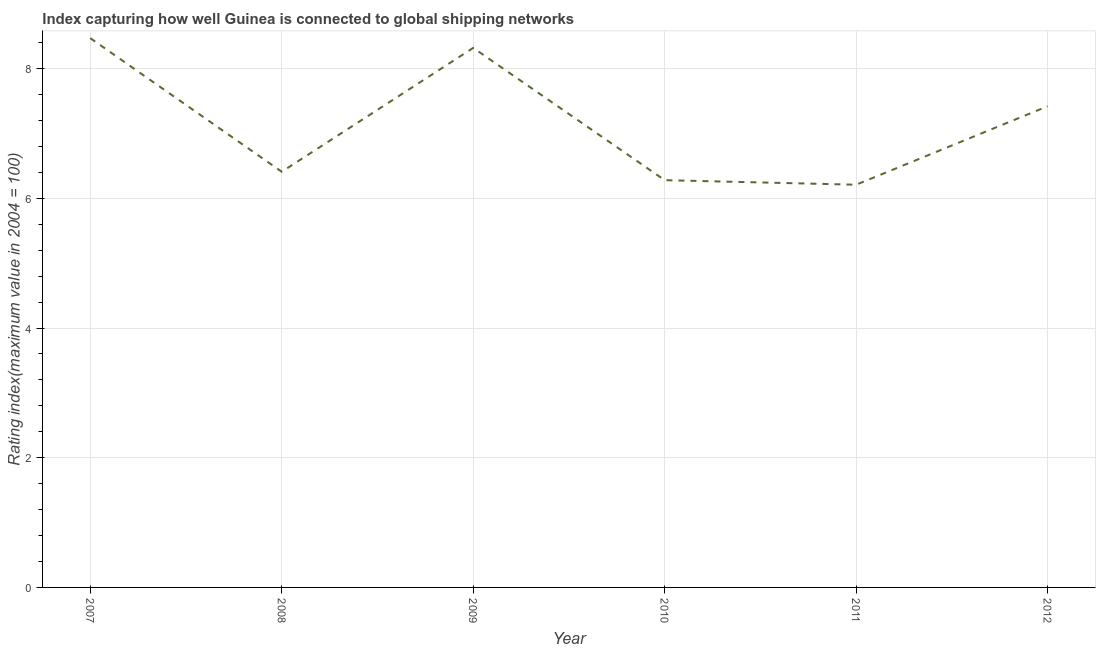What is the liner shipping connectivity index in 2009?
Offer a terse response. 8.32. Across all years, what is the maximum liner shipping connectivity index?
Your answer should be very brief. 8.47. Across all years, what is the minimum liner shipping connectivity index?
Your answer should be very brief. 6.21. In which year was the liner shipping connectivity index minimum?
Keep it short and to the point. 2011. What is the sum of the liner shipping connectivity index?
Your answer should be compact. 43.11. What is the difference between the liner shipping connectivity index in 2011 and 2012?
Your answer should be very brief. -1.21. What is the average liner shipping connectivity index per year?
Give a very brief answer. 7.19. What is the median liner shipping connectivity index?
Make the answer very short. 6.92. What is the ratio of the liner shipping connectivity index in 2008 to that in 2009?
Give a very brief answer. 0.77. Is the liner shipping connectivity index in 2007 less than that in 2011?
Make the answer very short. No. Is the difference between the liner shipping connectivity index in 2008 and 2010 greater than the difference between any two years?
Your response must be concise. No. What is the difference between the highest and the second highest liner shipping connectivity index?
Give a very brief answer. 0.15. What is the difference between the highest and the lowest liner shipping connectivity index?
Ensure brevity in your answer.  2.26. How many lines are there?
Ensure brevity in your answer.  1. Are the values on the major ticks of Y-axis written in scientific E-notation?
Your response must be concise. No. Does the graph contain any zero values?
Provide a short and direct response. No. Does the graph contain grids?
Offer a very short reply. Yes. What is the title of the graph?
Provide a short and direct response. Index capturing how well Guinea is connected to global shipping networks. What is the label or title of the X-axis?
Keep it short and to the point. Year. What is the label or title of the Y-axis?
Make the answer very short. Rating index(maximum value in 2004 = 100). What is the Rating index(maximum value in 2004 = 100) of 2007?
Make the answer very short. 8.47. What is the Rating index(maximum value in 2004 = 100) of 2008?
Keep it short and to the point. 6.41. What is the Rating index(maximum value in 2004 = 100) of 2009?
Give a very brief answer. 8.32. What is the Rating index(maximum value in 2004 = 100) of 2010?
Keep it short and to the point. 6.28. What is the Rating index(maximum value in 2004 = 100) in 2011?
Your response must be concise. 6.21. What is the Rating index(maximum value in 2004 = 100) in 2012?
Ensure brevity in your answer.  7.42. What is the difference between the Rating index(maximum value in 2004 = 100) in 2007 and 2008?
Keep it short and to the point. 2.06. What is the difference between the Rating index(maximum value in 2004 = 100) in 2007 and 2009?
Your answer should be compact. 0.15. What is the difference between the Rating index(maximum value in 2004 = 100) in 2007 and 2010?
Your answer should be very brief. 2.19. What is the difference between the Rating index(maximum value in 2004 = 100) in 2007 and 2011?
Make the answer very short. 2.26. What is the difference between the Rating index(maximum value in 2004 = 100) in 2008 and 2009?
Offer a very short reply. -1.91. What is the difference between the Rating index(maximum value in 2004 = 100) in 2008 and 2010?
Provide a short and direct response. 0.13. What is the difference between the Rating index(maximum value in 2004 = 100) in 2008 and 2011?
Ensure brevity in your answer.  0.2. What is the difference between the Rating index(maximum value in 2004 = 100) in 2008 and 2012?
Provide a succinct answer. -1.01. What is the difference between the Rating index(maximum value in 2004 = 100) in 2009 and 2010?
Keep it short and to the point. 2.04. What is the difference between the Rating index(maximum value in 2004 = 100) in 2009 and 2011?
Your response must be concise. 2.11. What is the difference between the Rating index(maximum value in 2004 = 100) in 2009 and 2012?
Ensure brevity in your answer.  0.9. What is the difference between the Rating index(maximum value in 2004 = 100) in 2010 and 2011?
Your answer should be compact. 0.07. What is the difference between the Rating index(maximum value in 2004 = 100) in 2010 and 2012?
Give a very brief answer. -1.14. What is the difference between the Rating index(maximum value in 2004 = 100) in 2011 and 2012?
Offer a very short reply. -1.21. What is the ratio of the Rating index(maximum value in 2004 = 100) in 2007 to that in 2008?
Provide a succinct answer. 1.32. What is the ratio of the Rating index(maximum value in 2004 = 100) in 2007 to that in 2009?
Keep it short and to the point. 1.02. What is the ratio of the Rating index(maximum value in 2004 = 100) in 2007 to that in 2010?
Make the answer very short. 1.35. What is the ratio of the Rating index(maximum value in 2004 = 100) in 2007 to that in 2011?
Your answer should be compact. 1.36. What is the ratio of the Rating index(maximum value in 2004 = 100) in 2007 to that in 2012?
Your response must be concise. 1.14. What is the ratio of the Rating index(maximum value in 2004 = 100) in 2008 to that in 2009?
Provide a short and direct response. 0.77. What is the ratio of the Rating index(maximum value in 2004 = 100) in 2008 to that in 2011?
Provide a succinct answer. 1.03. What is the ratio of the Rating index(maximum value in 2004 = 100) in 2008 to that in 2012?
Give a very brief answer. 0.86. What is the ratio of the Rating index(maximum value in 2004 = 100) in 2009 to that in 2010?
Keep it short and to the point. 1.32. What is the ratio of the Rating index(maximum value in 2004 = 100) in 2009 to that in 2011?
Your answer should be very brief. 1.34. What is the ratio of the Rating index(maximum value in 2004 = 100) in 2009 to that in 2012?
Provide a short and direct response. 1.12. What is the ratio of the Rating index(maximum value in 2004 = 100) in 2010 to that in 2012?
Make the answer very short. 0.85. What is the ratio of the Rating index(maximum value in 2004 = 100) in 2011 to that in 2012?
Make the answer very short. 0.84. 